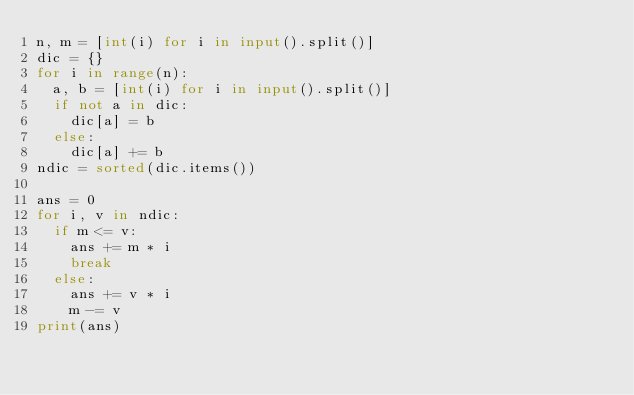<code> <loc_0><loc_0><loc_500><loc_500><_Python_>n, m = [int(i) for i in input().split()]
dic = {}
for i in range(n):
  a, b = [int(i) for i in input().split()]
  if not a in dic:
    dic[a] = b
  else:
    dic[a] += b
ndic = sorted(dic.items())

ans = 0
for i, v in ndic:
  if m <= v:
    ans += m * i
    break
  else:
    ans += v * i
    m -= v
print(ans)</code> 